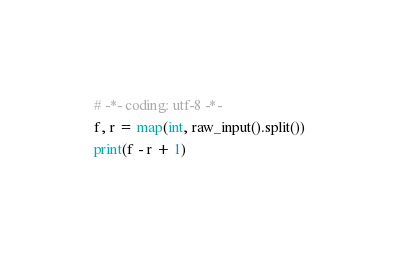<code> <loc_0><loc_0><loc_500><loc_500><_Python_># -*- coding: utf-8 -*-
f, r = map(int, raw_input().split())
print(f - r + 1)</code> 